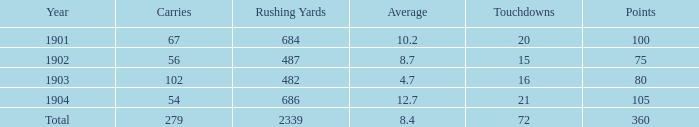What is the total number of rushing yards associated with averages over 8.4 and fewer than 54 carries? 0.0. 